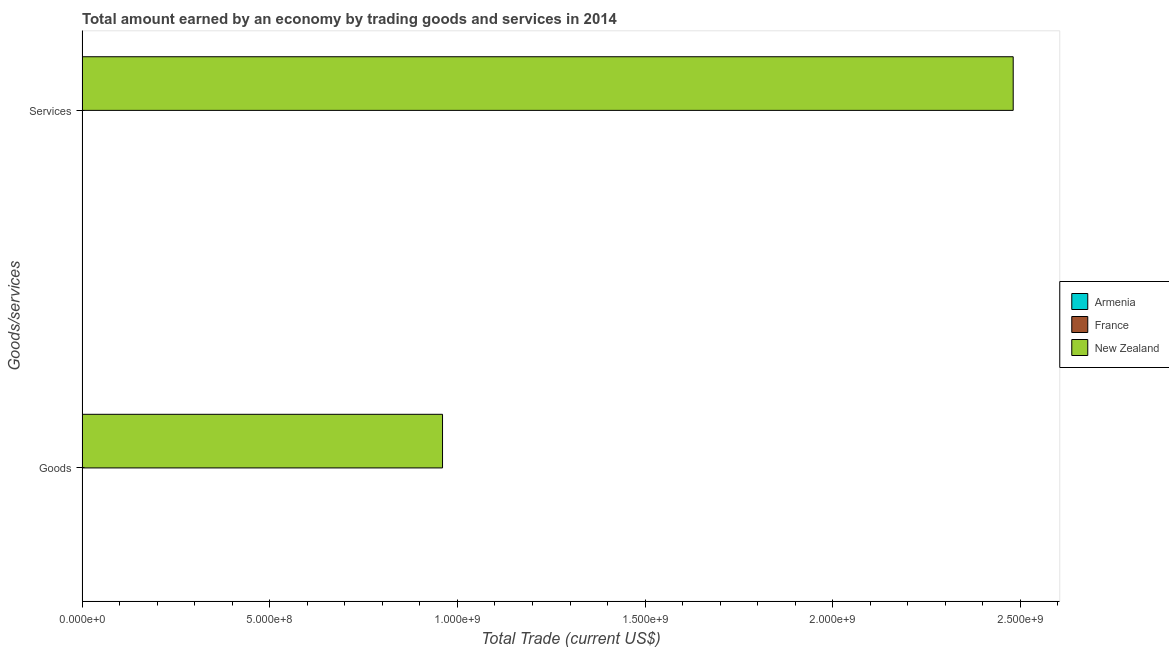Are the number of bars on each tick of the Y-axis equal?
Provide a short and direct response. Yes. What is the label of the 2nd group of bars from the top?
Offer a very short reply. Goods. Across all countries, what is the maximum amount earned by trading goods?
Keep it short and to the point. 9.60e+08. Across all countries, what is the minimum amount earned by trading goods?
Offer a very short reply. 0. In which country was the amount earned by trading services maximum?
Your answer should be compact. New Zealand. What is the total amount earned by trading goods in the graph?
Offer a very short reply. 9.60e+08. What is the difference between the amount earned by trading goods in Armenia and the amount earned by trading services in New Zealand?
Your response must be concise. -2.48e+09. What is the average amount earned by trading services per country?
Offer a very short reply. 8.27e+08. What is the difference between the amount earned by trading services and amount earned by trading goods in New Zealand?
Offer a very short reply. 1.52e+09. In how many countries, is the amount earned by trading goods greater than the average amount earned by trading goods taken over all countries?
Offer a terse response. 1. How many bars are there?
Provide a short and direct response. 2. What is the difference between two consecutive major ticks on the X-axis?
Provide a succinct answer. 5.00e+08. Does the graph contain any zero values?
Your answer should be compact. Yes. Does the graph contain grids?
Offer a terse response. No. Where does the legend appear in the graph?
Your answer should be very brief. Center right. What is the title of the graph?
Ensure brevity in your answer.  Total amount earned by an economy by trading goods and services in 2014. What is the label or title of the X-axis?
Offer a terse response. Total Trade (current US$). What is the label or title of the Y-axis?
Provide a short and direct response. Goods/services. What is the Total Trade (current US$) in France in Goods?
Offer a terse response. 0. What is the Total Trade (current US$) in New Zealand in Goods?
Keep it short and to the point. 9.60e+08. What is the Total Trade (current US$) in New Zealand in Services?
Offer a very short reply. 2.48e+09. Across all Goods/services, what is the maximum Total Trade (current US$) of New Zealand?
Keep it short and to the point. 2.48e+09. Across all Goods/services, what is the minimum Total Trade (current US$) in New Zealand?
Make the answer very short. 9.60e+08. What is the total Total Trade (current US$) in Armenia in the graph?
Your response must be concise. 0. What is the total Total Trade (current US$) of New Zealand in the graph?
Offer a very short reply. 3.44e+09. What is the difference between the Total Trade (current US$) of New Zealand in Goods and that in Services?
Your answer should be compact. -1.52e+09. What is the average Total Trade (current US$) in New Zealand per Goods/services?
Your response must be concise. 1.72e+09. What is the ratio of the Total Trade (current US$) in New Zealand in Goods to that in Services?
Ensure brevity in your answer.  0.39. What is the difference between the highest and the second highest Total Trade (current US$) of New Zealand?
Give a very brief answer. 1.52e+09. What is the difference between the highest and the lowest Total Trade (current US$) of New Zealand?
Ensure brevity in your answer.  1.52e+09. 